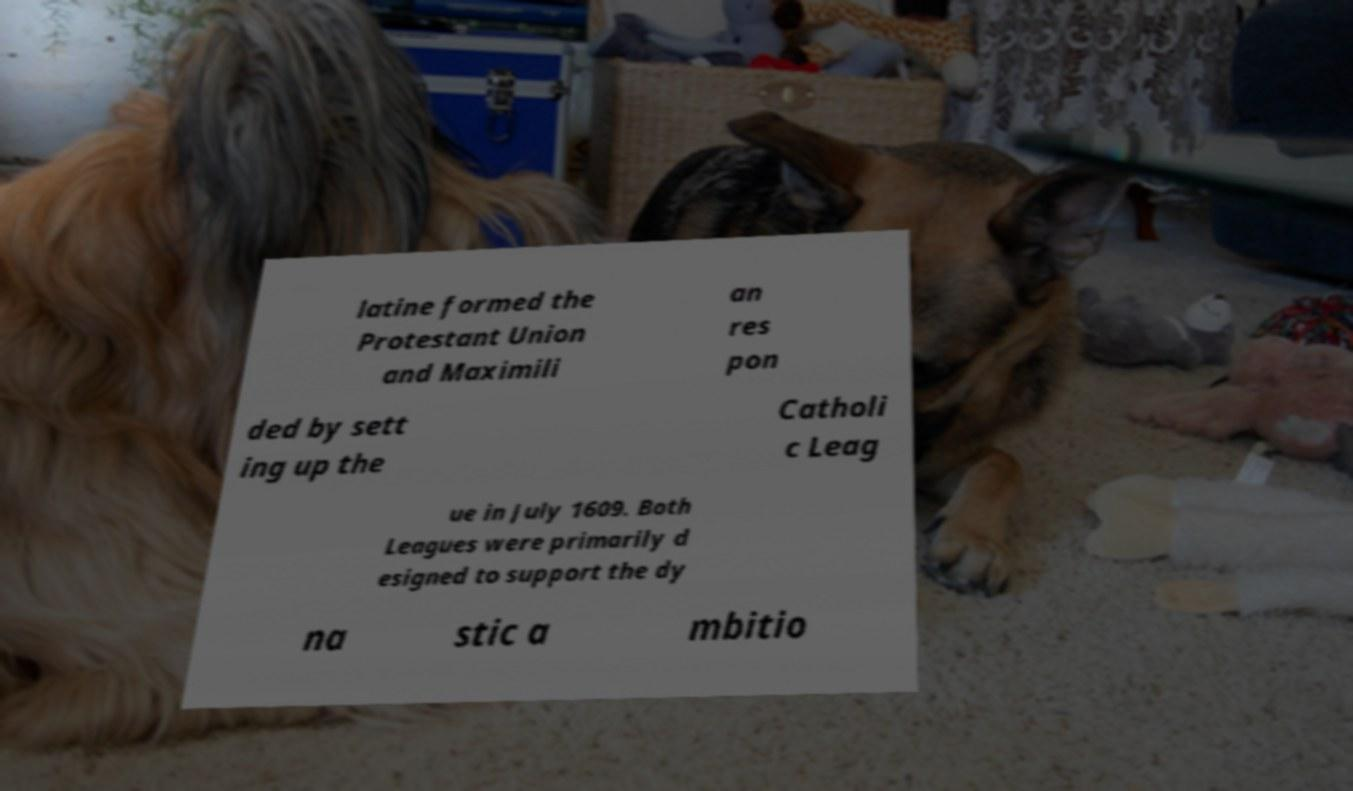Please read and relay the text visible in this image. What does it say? latine formed the Protestant Union and Maximili an res pon ded by sett ing up the Catholi c Leag ue in July 1609. Both Leagues were primarily d esigned to support the dy na stic a mbitio 